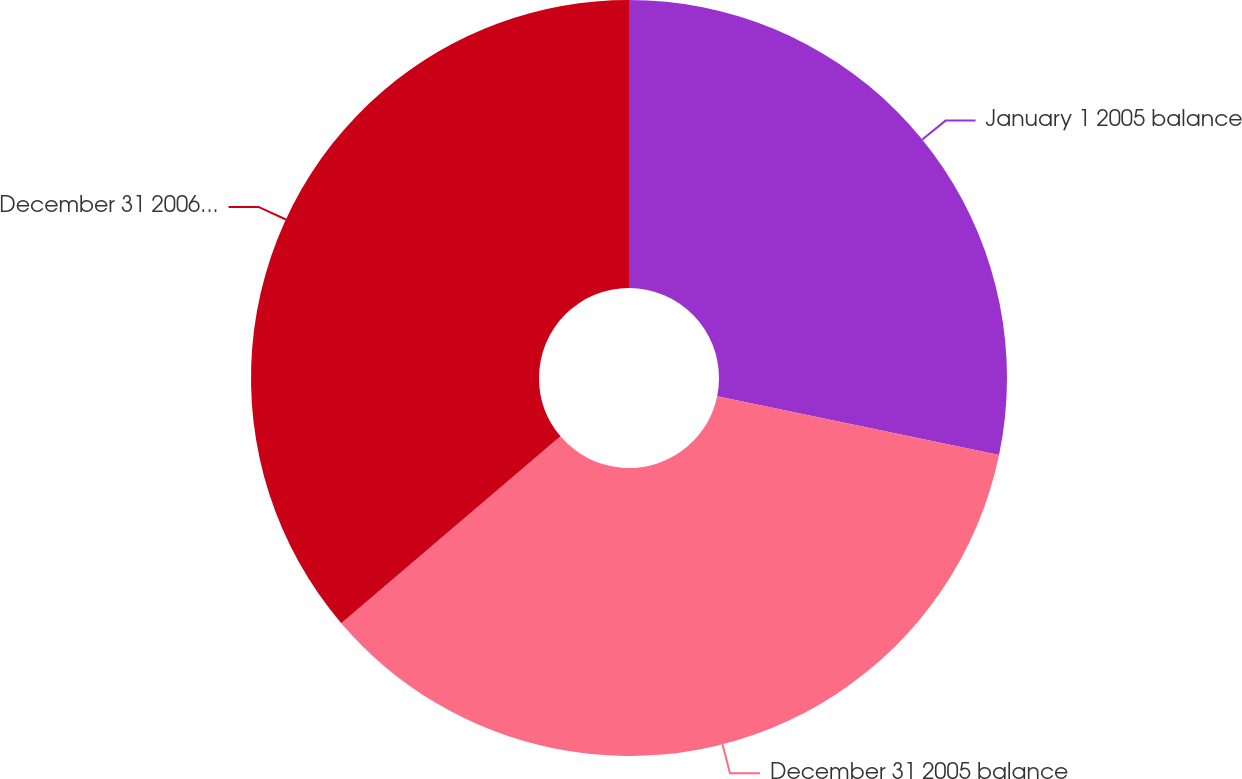Convert chart. <chart><loc_0><loc_0><loc_500><loc_500><pie_chart><fcel>January 1 2005 balance<fcel>December 31 2005 balance<fcel>December 31 2006 balance<nl><fcel>28.27%<fcel>35.5%<fcel>36.23%<nl></chart> 